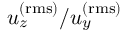<formula> <loc_0><loc_0><loc_500><loc_500>u _ { z } ^ { ( r m s ) } / u _ { y } ^ { ( r m s ) }</formula> 